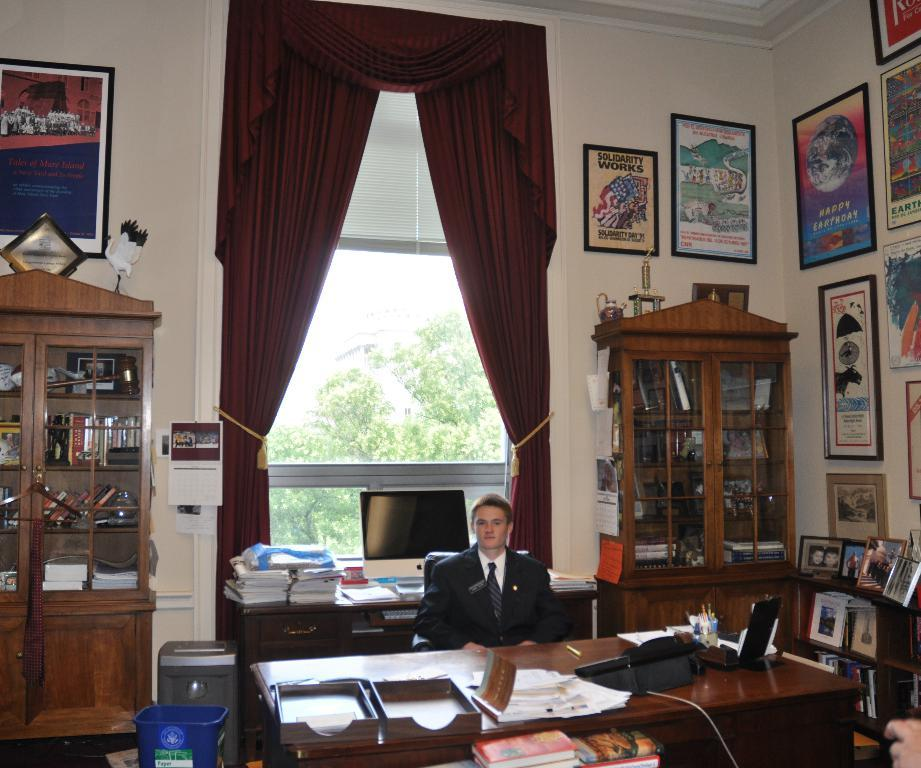<image>
Describe the image concisely. A man sitting near a desk in an office with pictures such as earthday and solidarity. 